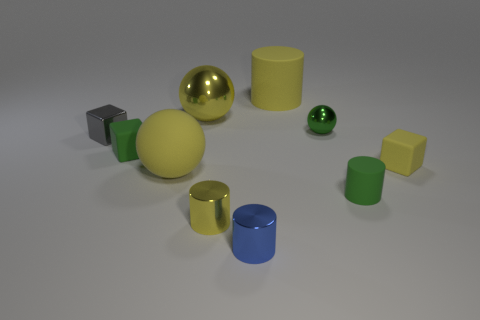Is the color of the large cylinder the same as the metal thing that is on the left side of the big matte ball?
Ensure brevity in your answer.  No. What number of big balls are there?
Your response must be concise. 2. What number of objects are either small yellow cylinders or shiny things?
Ensure brevity in your answer.  5. There is a rubber block that is the same color as the tiny sphere; what is its size?
Offer a terse response. Small. Are there any small green shiny objects in front of the gray cube?
Give a very brief answer. No. Are there more large yellow rubber cylinders that are to the left of the big shiny sphere than large balls behind the gray metal object?
Keep it short and to the point. No. There is a yellow matte thing that is the same shape as the tiny blue metal thing; what is its size?
Ensure brevity in your answer.  Large. What number of cylinders are either shiny objects or small gray things?
Keep it short and to the point. 2. What is the material of the small cube that is the same color as the tiny rubber cylinder?
Provide a short and direct response. Rubber. Are there fewer big objects in front of the blue shiny thing than tiny green matte things in front of the tiny yellow matte object?
Provide a short and direct response. Yes. 